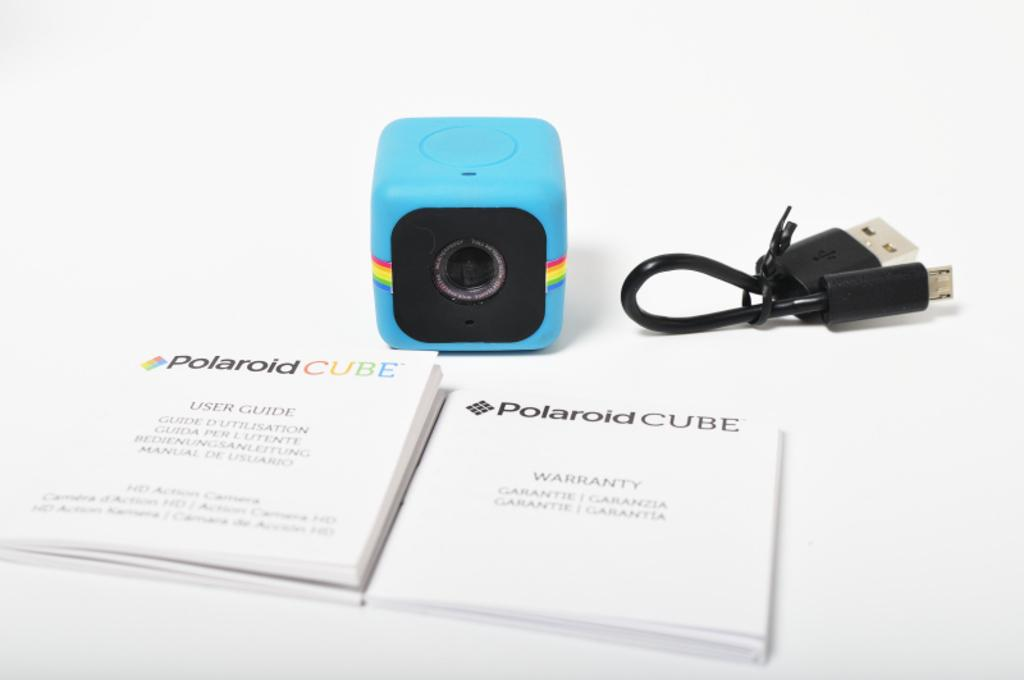What objects can be seen in the image? There are books and a camera in the image. What additional item is present in the image? There is a cable in the image. What color is the background of the image? The background of the image is white. Where is the crook hiding in the image? There is no crook present in the image. What type of camp can be seen in the background of the image? There is no camp visible in the image, as the background is white. 